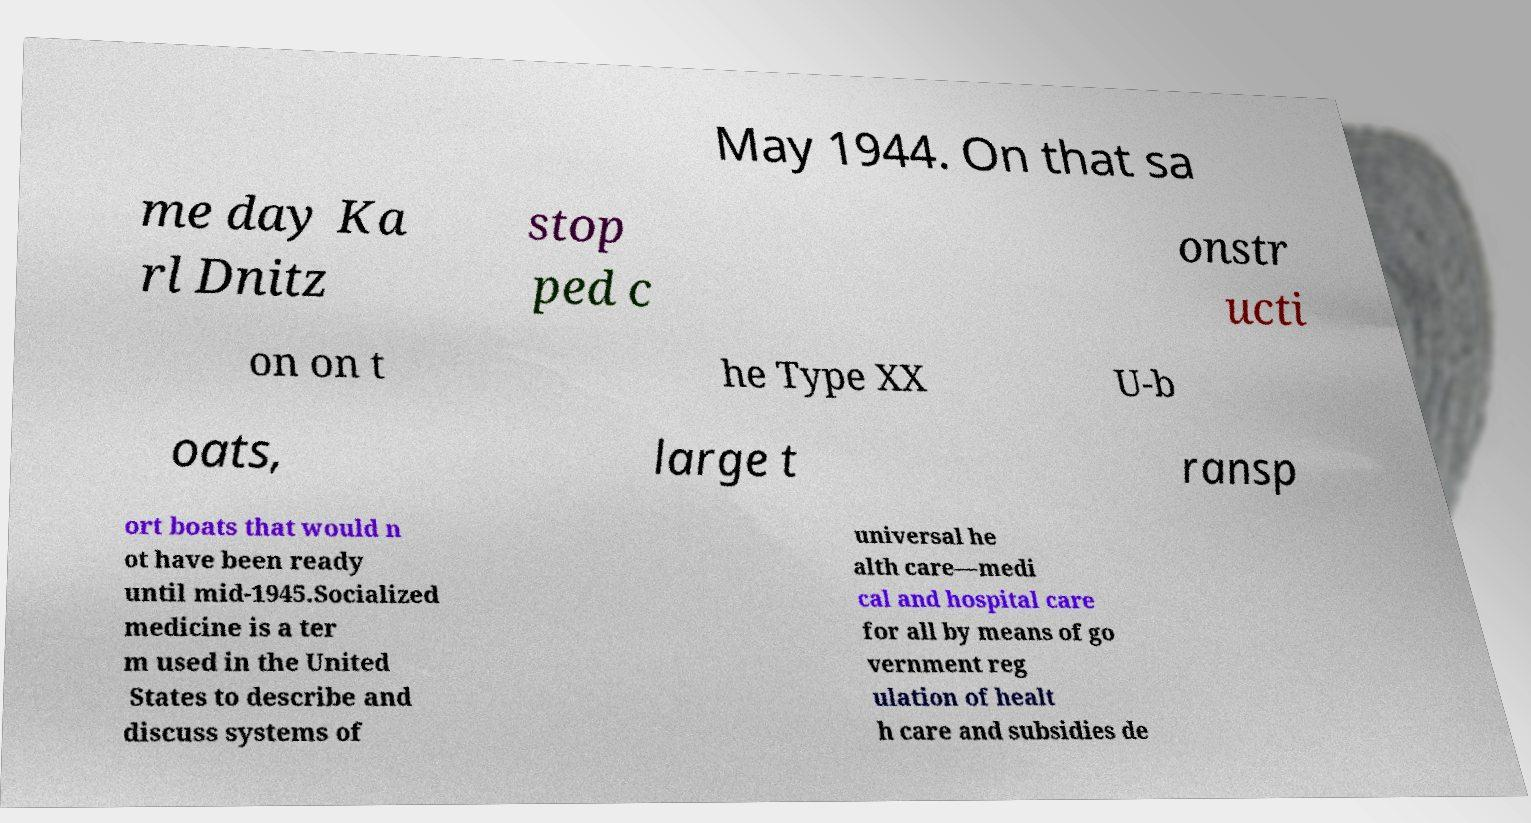Can you read and provide the text displayed in the image?This photo seems to have some interesting text. Can you extract and type it out for me? May 1944. On that sa me day Ka rl Dnitz stop ped c onstr ucti on on t he Type XX U-b oats, large t ransp ort boats that would n ot have been ready until mid-1945.Socialized medicine is a ter m used in the United States to describe and discuss systems of universal he alth care—medi cal and hospital care for all by means of go vernment reg ulation of healt h care and subsidies de 